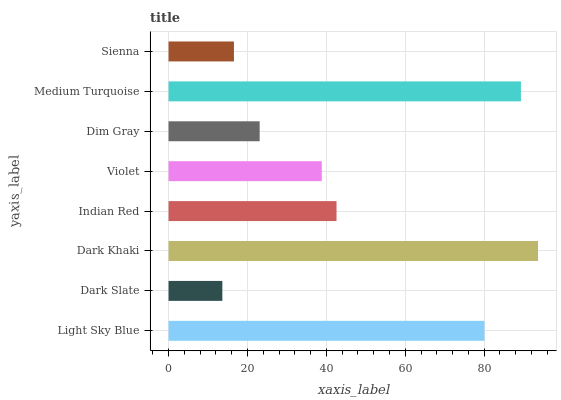Is Dark Slate the minimum?
Answer yes or no. Yes. Is Dark Khaki the maximum?
Answer yes or no. Yes. Is Dark Khaki the minimum?
Answer yes or no. No. Is Dark Slate the maximum?
Answer yes or no. No. Is Dark Khaki greater than Dark Slate?
Answer yes or no. Yes. Is Dark Slate less than Dark Khaki?
Answer yes or no. Yes. Is Dark Slate greater than Dark Khaki?
Answer yes or no. No. Is Dark Khaki less than Dark Slate?
Answer yes or no. No. Is Indian Red the high median?
Answer yes or no. Yes. Is Violet the low median?
Answer yes or no. Yes. Is Medium Turquoise the high median?
Answer yes or no. No. Is Indian Red the low median?
Answer yes or no. No. 